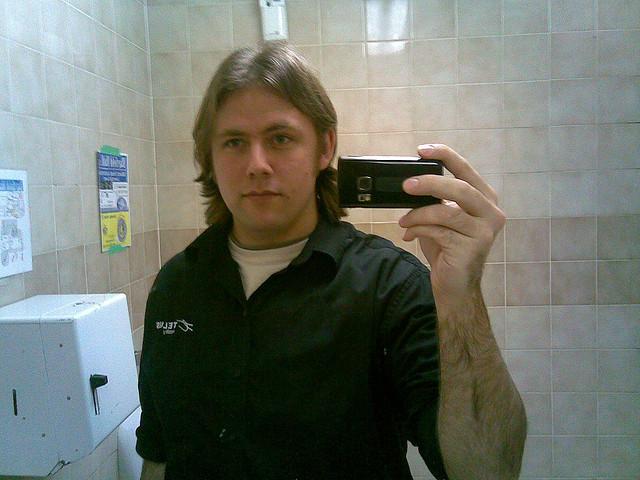What does the man have on his neck?
Answer briefly. Collar. Does he have long hair?
Quick response, please. Yes. What room is this?
Quick response, please. Bathroom. Is he taking a side selfie?
Concise answer only. Yes. 